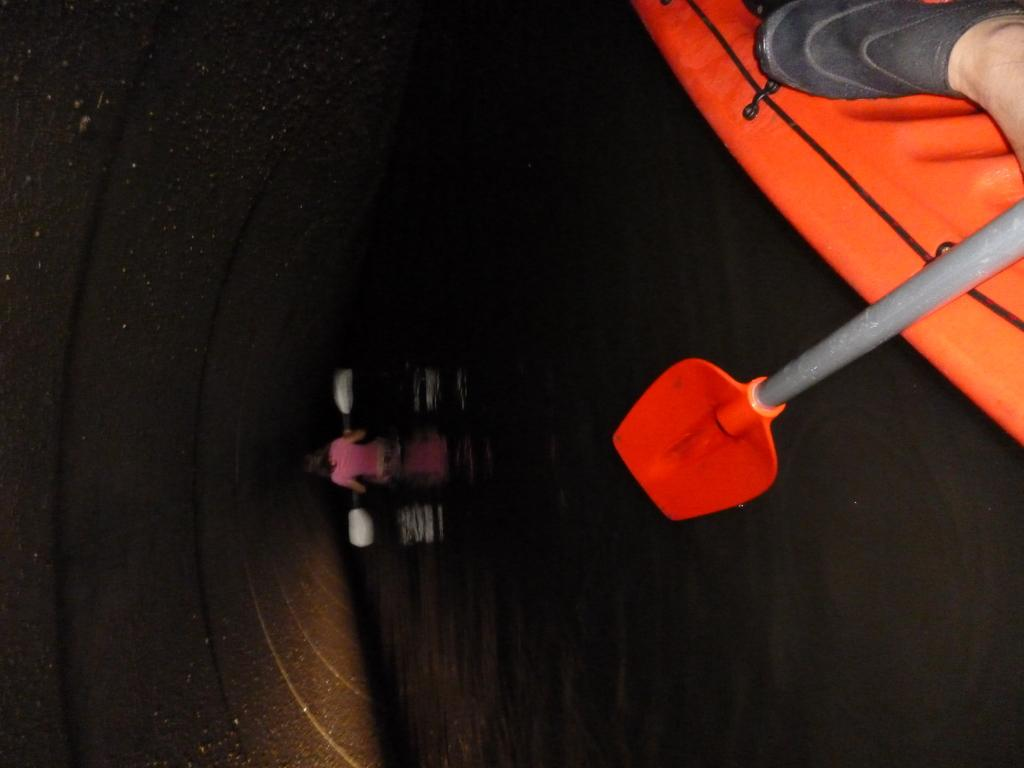What is the vantage point of the image? The image is captured from a boat. What is the boat situated on? The boat is on a water surface. Can you describe any activity happening in the distance? There is a person sailing a boat in the distance. What type of eggnog is being served on the boat in the image? There is no eggnog present in the image; it is a boat on a water surface with a person sailing a boat in the distance. 